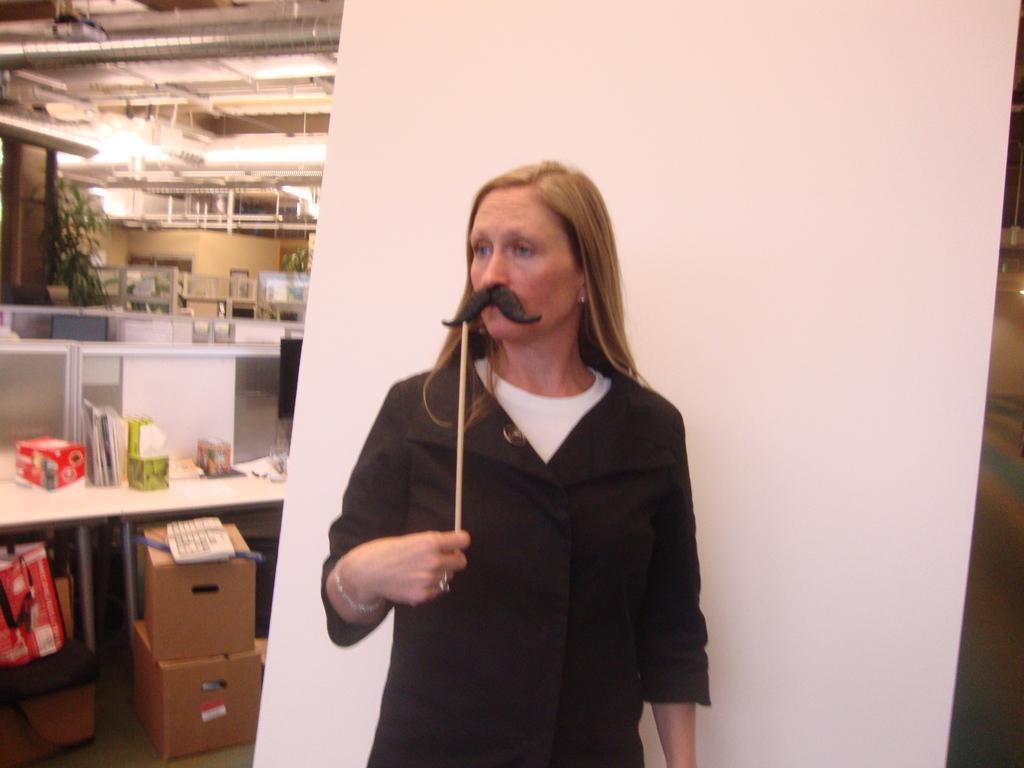Could you give a brief overview of what you see in this image? In the center of the image we can see a lady standing and holding an object. There are desks and at the bottom there are cardboard boxes. We can see objects. In the background there are lights and we can see a curtain. 